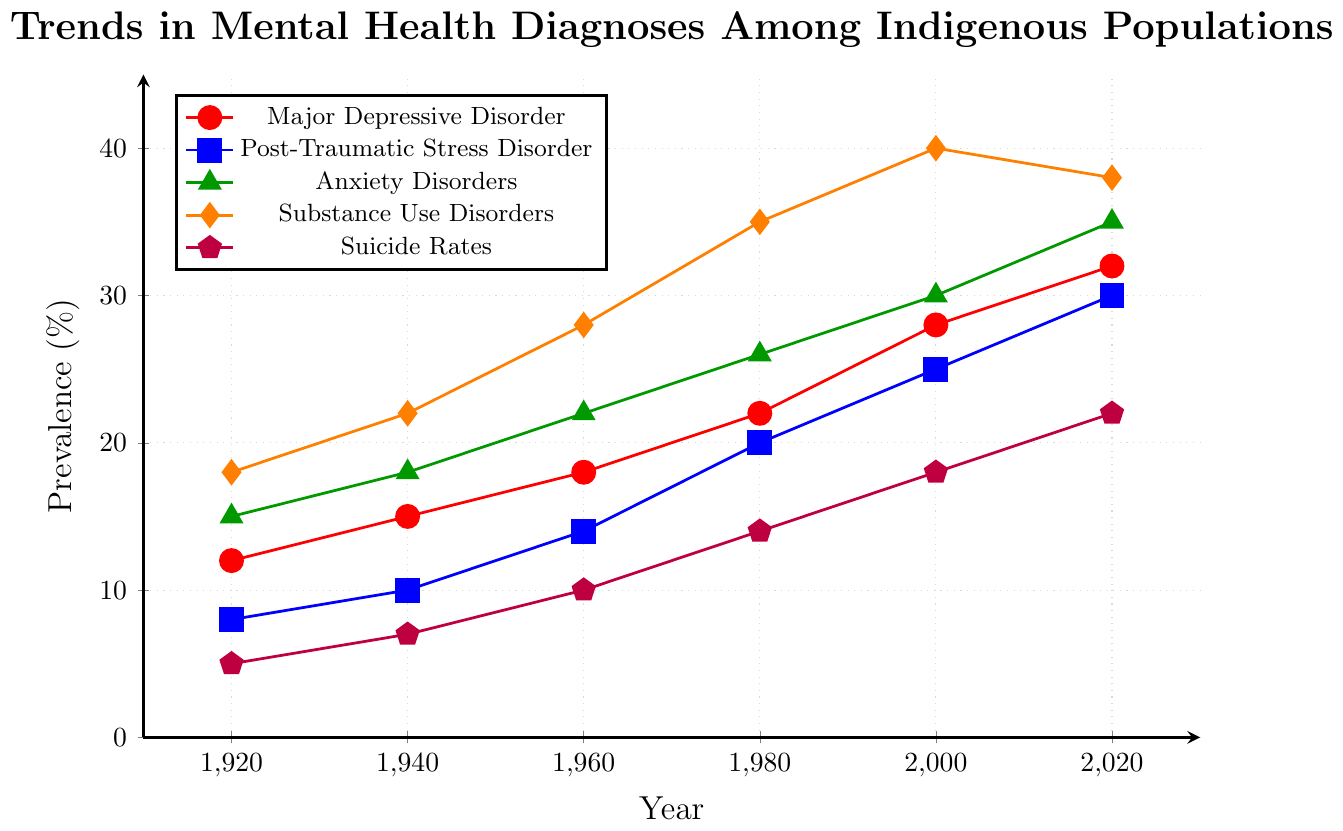What is the trend of Major Depressive Disorder over the past century? By observing the red line, we can see that the prevalence of Major Depressive Disorder has been steadily increasing from 12% in 1920 to 32% in 2020.
Answer: Steadily increasing Which disorder had the highest prevalence in 1980? By comparing the heights of the lines in 1980, the orange line representing Substance Use Disorders has the highest prevalence at 35%.
Answer: Substance Use Disorders How much did the prevalence of Post-Traumatic Stress Disorder increase from 1960 to 2000? The prevalence of PTSD was 14% in 1960 and 25% in 2000. The increase is 25% - 14% = 11%.
Answer: 11% Which mental health issue saw a decline between 2000 and 2020? By looking at the lines from 2000 to 2020, only the orange line (Substance Use Disorders) shows a slight decline from 40% to 38%.
Answer: Substance Use Disorders In which year did Anxiety Disorders and Substance Use Disorders have the same prevalence? The green and orange lines intersect at 2020, both having nearly the same prevalence of around 35%.
Answer: 2020 How much more prevalent was Suicide Rates in 2020 compared to 1920? Suicide Rates in 2020 were 22%, and in 1920 they were 5%. The difference is 22% - 5% = 17%.
Answer: 17% What is the average prevalence of Anxiety Disorders over the periods shown? The prevalence values for Anxiety Disorders are 15, 18, 22, 26, 30, and 35. Adding these up gives 146, and there are 6 periods, so the average is 146/6 ≈ 24.3%.
Answer: 24.3% Which disorder had the smallest increase in prevalence over the past century? By comparing the distance between end and start points of the lines, Suicide Rates (purple line) had the smallest increase, from 5% to 22%, an increase of 17%.
Answer: Suicide Rates If the trends continue, which disorder would you predict to have the highest prevalence in 2040? Based on the given trends, Substance Use Disorders (orange line) consistently had high values, but we should also consider recent trends where Anxiety Disorders (green line) shows a constant increasing trend. This hints that Anxiety Disorders may potentially have the highest prevalence if the trend continues.
Answer: Anxiety Disorders From the visual attributes, which color represents Major Depressive Disorder? By observing the legend, the Major Depressive Disorder is represented by the red color.
Answer: Red 